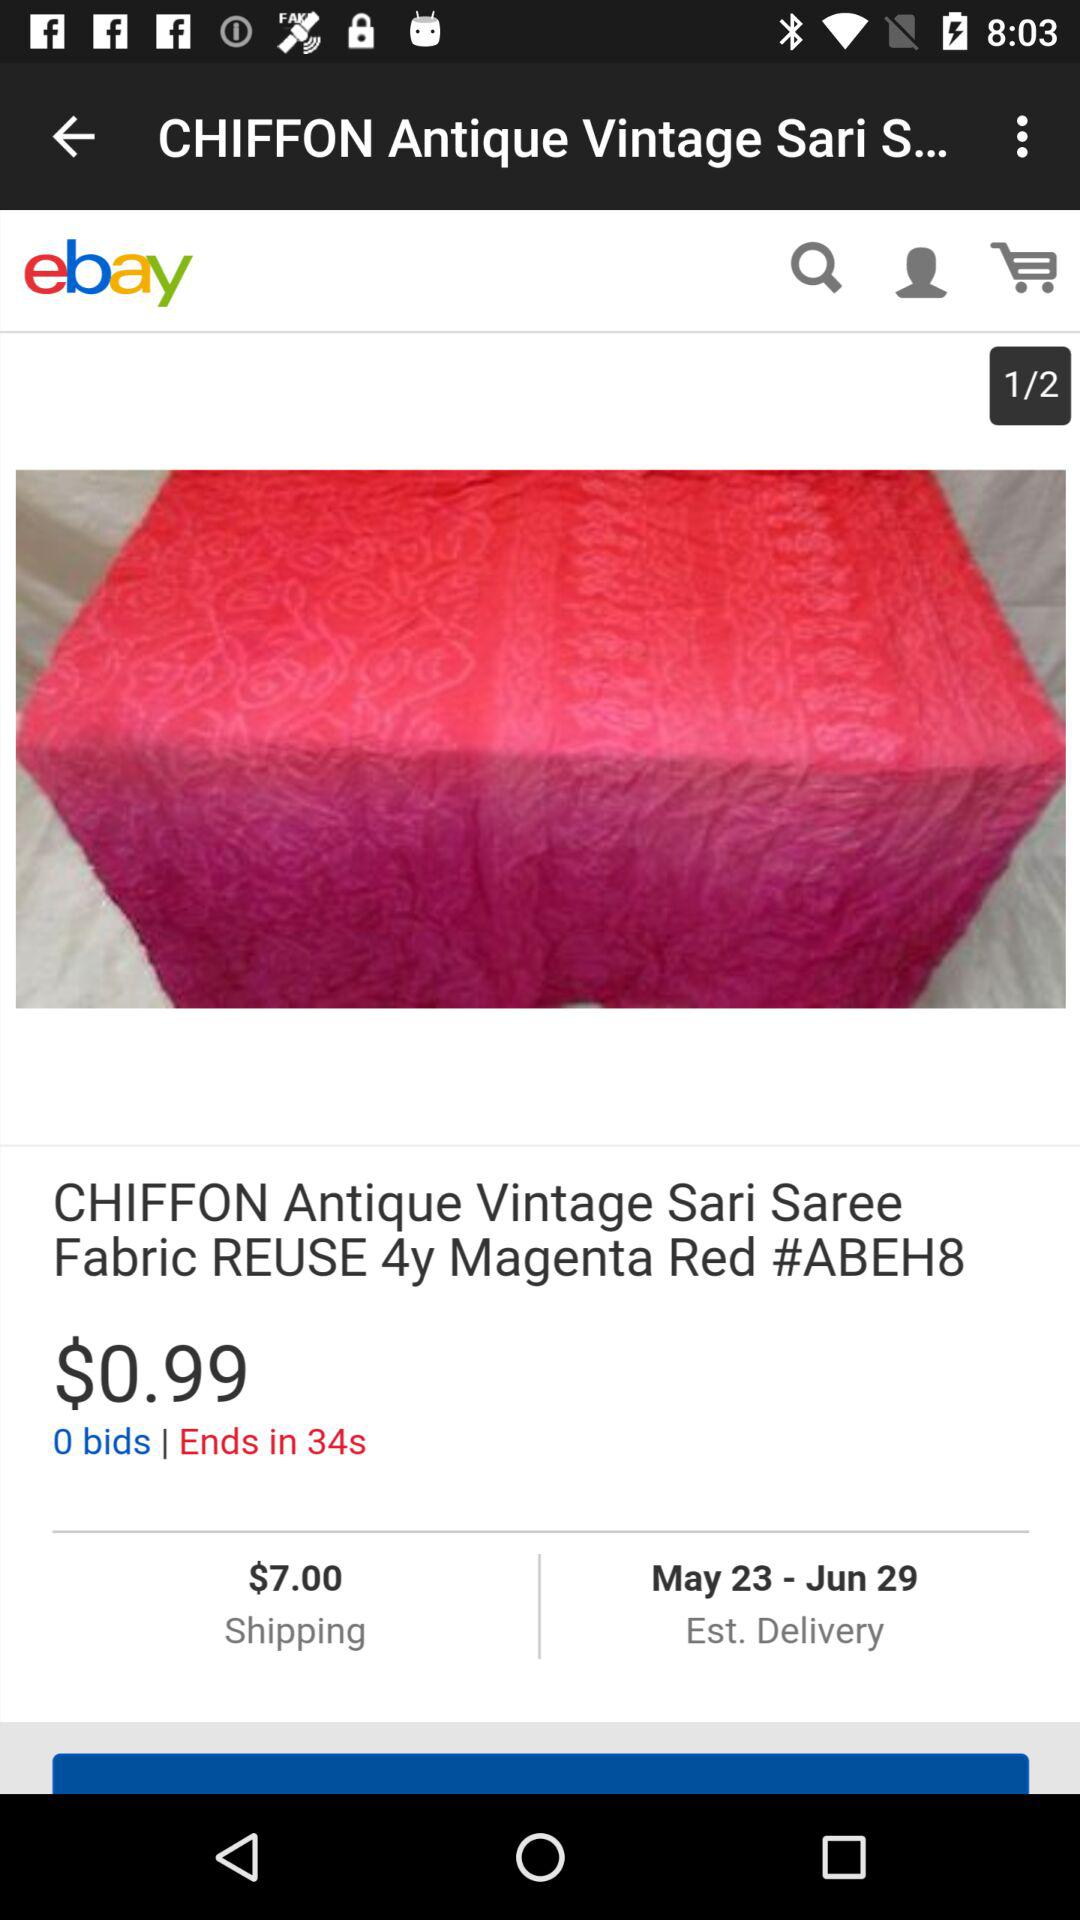What is the estimated delivery date of the Chiffon Antique vintage saree fabric? The estimated delivery date is May 23 to June 29. 